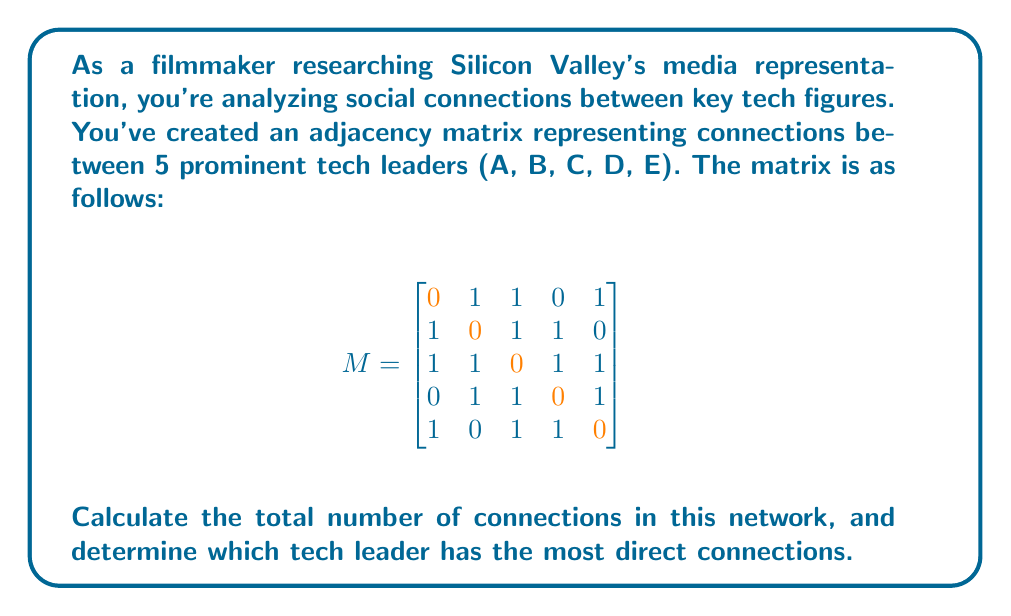Show me your answer to this math problem. To solve this problem, we'll follow these steps:

1. Count the total number of connections:
   - In an adjacency matrix, each '1' represents a connection.
   - We only need to count the upper (or lower) triangular part of the matrix to avoid counting each connection twice.
   - Sum of upper triangular part:
     $$(1+1+0+1) + (1+1+0) + (1+1) + (1) = 4 + 2 + 2 + 1 = 9$$

2. Determine the tech leader with most connections:
   - Count '1's in each row (or column, as the matrix is symmetric):
     A: 3 connections (sum of first row)
     B: 3 connections (sum of second row)
     C: 4 connections (sum of third row)
     D: 3 connections (sum of fourth row)
     E: 3 connections (sum of fifth row)

Therefore, the total number of connections is 9, and tech leader C has the most direct connections (4).
Answer: 9 total connections; Leader C has most (4) 